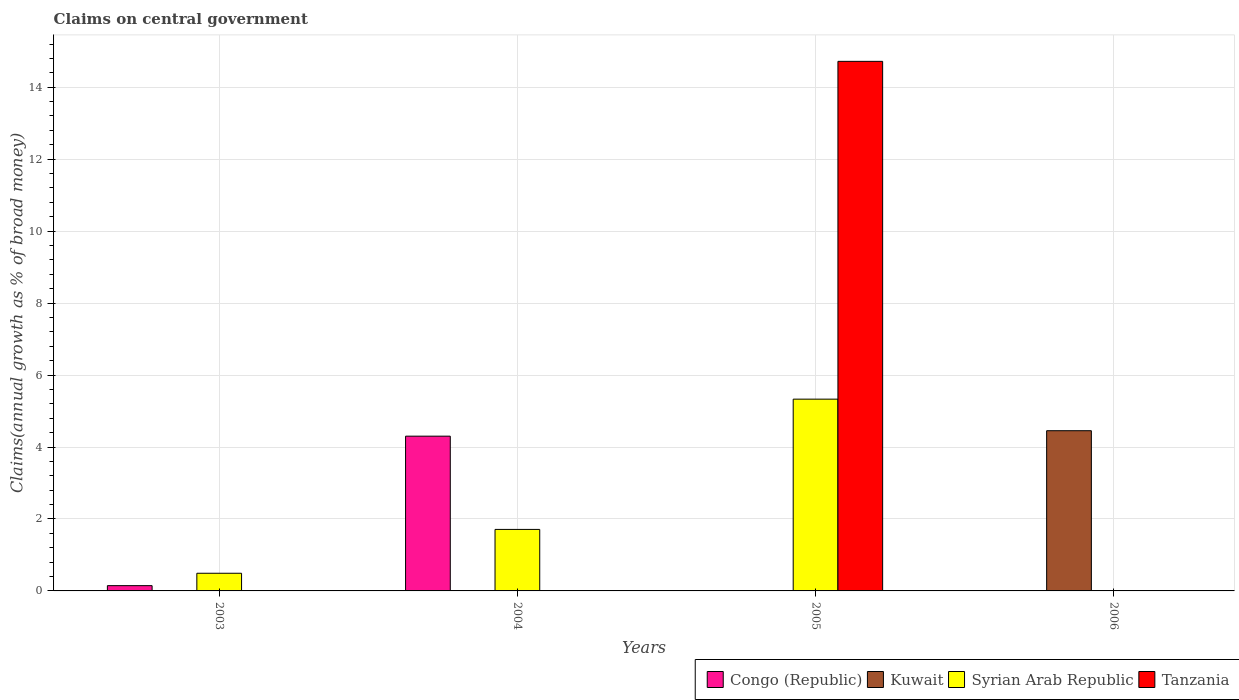How many different coloured bars are there?
Your answer should be compact. 4. How many bars are there on the 3rd tick from the left?
Provide a short and direct response. 2. In how many cases, is the number of bars for a given year not equal to the number of legend labels?
Provide a succinct answer. 4. Across all years, what is the maximum percentage of broad money claimed on centeral government in Syrian Arab Republic?
Offer a very short reply. 5.33. In which year was the percentage of broad money claimed on centeral government in Tanzania maximum?
Ensure brevity in your answer.  2005. What is the total percentage of broad money claimed on centeral government in Kuwait in the graph?
Offer a terse response. 4.45. What is the difference between the percentage of broad money claimed on centeral government in Syrian Arab Republic in 2003 and that in 2004?
Make the answer very short. -1.22. What is the difference between the percentage of broad money claimed on centeral government in Syrian Arab Republic in 2003 and the percentage of broad money claimed on centeral government in Tanzania in 2005?
Offer a very short reply. -14.23. What is the average percentage of broad money claimed on centeral government in Tanzania per year?
Ensure brevity in your answer.  3.68. In the year 2003, what is the difference between the percentage of broad money claimed on centeral government in Syrian Arab Republic and percentage of broad money claimed on centeral government in Congo (Republic)?
Offer a very short reply. 0.34. In how many years, is the percentage of broad money claimed on centeral government in Kuwait greater than 10 %?
Your answer should be very brief. 0. What is the ratio of the percentage of broad money claimed on centeral government in Syrian Arab Republic in 2003 to that in 2004?
Offer a terse response. 0.29. Is the percentage of broad money claimed on centeral government in Syrian Arab Republic in 2003 less than that in 2005?
Provide a succinct answer. Yes. What is the difference between the highest and the second highest percentage of broad money claimed on centeral government in Syrian Arab Republic?
Give a very brief answer. 3.62. What is the difference between the highest and the lowest percentage of broad money claimed on centeral government in Tanzania?
Offer a terse response. 14.72. Is the sum of the percentage of broad money claimed on centeral government in Syrian Arab Republic in 2004 and 2005 greater than the maximum percentage of broad money claimed on centeral government in Congo (Republic) across all years?
Give a very brief answer. Yes. Is it the case that in every year, the sum of the percentage of broad money claimed on centeral government in Tanzania and percentage of broad money claimed on centeral government in Congo (Republic) is greater than the percentage of broad money claimed on centeral government in Kuwait?
Offer a terse response. No. How many bars are there?
Your answer should be very brief. 7. What is the difference between two consecutive major ticks on the Y-axis?
Provide a short and direct response. 2. Does the graph contain any zero values?
Give a very brief answer. Yes. Does the graph contain grids?
Offer a terse response. Yes. Where does the legend appear in the graph?
Your response must be concise. Bottom right. How many legend labels are there?
Provide a short and direct response. 4. What is the title of the graph?
Keep it short and to the point. Claims on central government. What is the label or title of the Y-axis?
Provide a succinct answer. Claims(annual growth as % of broad money). What is the Claims(annual growth as % of broad money) of Congo (Republic) in 2003?
Make the answer very short. 0.15. What is the Claims(annual growth as % of broad money) in Syrian Arab Republic in 2003?
Your answer should be very brief. 0.49. What is the Claims(annual growth as % of broad money) in Congo (Republic) in 2004?
Offer a very short reply. 4.3. What is the Claims(annual growth as % of broad money) of Kuwait in 2004?
Your response must be concise. 0. What is the Claims(annual growth as % of broad money) of Syrian Arab Republic in 2004?
Offer a terse response. 1.71. What is the Claims(annual growth as % of broad money) of Tanzania in 2004?
Make the answer very short. 0. What is the Claims(annual growth as % of broad money) in Congo (Republic) in 2005?
Make the answer very short. 0. What is the Claims(annual growth as % of broad money) in Syrian Arab Republic in 2005?
Make the answer very short. 5.33. What is the Claims(annual growth as % of broad money) of Tanzania in 2005?
Offer a terse response. 14.72. What is the Claims(annual growth as % of broad money) in Congo (Republic) in 2006?
Give a very brief answer. 0. What is the Claims(annual growth as % of broad money) of Kuwait in 2006?
Provide a short and direct response. 4.45. What is the Claims(annual growth as % of broad money) in Tanzania in 2006?
Provide a succinct answer. 0. Across all years, what is the maximum Claims(annual growth as % of broad money) of Congo (Republic)?
Provide a succinct answer. 4.3. Across all years, what is the maximum Claims(annual growth as % of broad money) in Kuwait?
Provide a short and direct response. 4.45. Across all years, what is the maximum Claims(annual growth as % of broad money) of Syrian Arab Republic?
Ensure brevity in your answer.  5.33. Across all years, what is the maximum Claims(annual growth as % of broad money) of Tanzania?
Give a very brief answer. 14.72. Across all years, what is the minimum Claims(annual growth as % of broad money) of Congo (Republic)?
Your response must be concise. 0. Across all years, what is the minimum Claims(annual growth as % of broad money) of Kuwait?
Offer a very short reply. 0. What is the total Claims(annual growth as % of broad money) of Congo (Republic) in the graph?
Provide a succinct answer. 4.45. What is the total Claims(annual growth as % of broad money) in Kuwait in the graph?
Provide a succinct answer. 4.45. What is the total Claims(annual growth as % of broad money) in Syrian Arab Republic in the graph?
Give a very brief answer. 7.53. What is the total Claims(annual growth as % of broad money) in Tanzania in the graph?
Your answer should be compact. 14.72. What is the difference between the Claims(annual growth as % of broad money) in Congo (Republic) in 2003 and that in 2004?
Keep it short and to the point. -4.15. What is the difference between the Claims(annual growth as % of broad money) in Syrian Arab Republic in 2003 and that in 2004?
Give a very brief answer. -1.22. What is the difference between the Claims(annual growth as % of broad money) of Syrian Arab Republic in 2003 and that in 2005?
Your answer should be very brief. -4.84. What is the difference between the Claims(annual growth as % of broad money) in Syrian Arab Republic in 2004 and that in 2005?
Provide a succinct answer. -3.62. What is the difference between the Claims(annual growth as % of broad money) in Congo (Republic) in 2003 and the Claims(annual growth as % of broad money) in Syrian Arab Republic in 2004?
Your answer should be very brief. -1.56. What is the difference between the Claims(annual growth as % of broad money) in Congo (Republic) in 2003 and the Claims(annual growth as % of broad money) in Syrian Arab Republic in 2005?
Your answer should be very brief. -5.18. What is the difference between the Claims(annual growth as % of broad money) of Congo (Republic) in 2003 and the Claims(annual growth as % of broad money) of Tanzania in 2005?
Ensure brevity in your answer.  -14.57. What is the difference between the Claims(annual growth as % of broad money) of Syrian Arab Republic in 2003 and the Claims(annual growth as % of broad money) of Tanzania in 2005?
Give a very brief answer. -14.23. What is the difference between the Claims(annual growth as % of broad money) in Congo (Republic) in 2003 and the Claims(annual growth as % of broad money) in Kuwait in 2006?
Your response must be concise. -4.31. What is the difference between the Claims(annual growth as % of broad money) in Congo (Republic) in 2004 and the Claims(annual growth as % of broad money) in Syrian Arab Republic in 2005?
Your answer should be very brief. -1.03. What is the difference between the Claims(annual growth as % of broad money) of Congo (Republic) in 2004 and the Claims(annual growth as % of broad money) of Tanzania in 2005?
Your answer should be very brief. -10.42. What is the difference between the Claims(annual growth as % of broad money) of Syrian Arab Republic in 2004 and the Claims(annual growth as % of broad money) of Tanzania in 2005?
Offer a very short reply. -13.01. What is the difference between the Claims(annual growth as % of broad money) in Congo (Republic) in 2004 and the Claims(annual growth as % of broad money) in Kuwait in 2006?
Your response must be concise. -0.15. What is the average Claims(annual growth as % of broad money) of Congo (Republic) per year?
Provide a succinct answer. 1.11. What is the average Claims(annual growth as % of broad money) in Kuwait per year?
Your response must be concise. 1.11. What is the average Claims(annual growth as % of broad money) in Syrian Arab Republic per year?
Keep it short and to the point. 1.88. What is the average Claims(annual growth as % of broad money) of Tanzania per year?
Give a very brief answer. 3.68. In the year 2003, what is the difference between the Claims(annual growth as % of broad money) in Congo (Republic) and Claims(annual growth as % of broad money) in Syrian Arab Republic?
Provide a succinct answer. -0.34. In the year 2004, what is the difference between the Claims(annual growth as % of broad money) in Congo (Republic) and Claims(annual growth as % of broad money) in Syrian Arab Republic?
Provide a succinct answer. 2.59. In the year 2005, what is the difference between the Claims(annual growth as % of broad money) of Syrian Arab Republic and Claims(annual growth as % of broad money) of Tanzania?
Your response must be concise. -9.39. What is the ratio of the Claims(annual growth as % of broad money) of Congo (Republic) in 2003 to that in 2004?
Offer a very short reply. 0.03. What is the ratio of the Claims(annual growth as % of broad money) of Syrian Arab Republic in 2003 to that in 2004?
Offer a very short reply. 0.29. What is the ratio of the Claims(annual growth as % of broad money) of Syrian Arab Republic in 2003 to that in 2005?
Give a very brief answer. 0.09. What is the ratio of the Claims(annual growth as % of broad money) in Syrian Arab Republic in 2004 to that in 2005?
Provide a short and direct response. 0.32. What is the difference between the highest and the second highest Claims(annual growth as % of broad money) in Syrian Arab Republic?
Offer a very short reply. 3.62. What is the difference between the highest and the lowest Claims(annual growth as % of broad money) in Congo (Republic)?
Your answer should be very brief. 4.3. What is the difference between the highest and the lowest Claims(annual growth as % of broad money) of Kuwait?
Your answer should be compact. 4.45. What is the difference between the highest and the lowest Claims(annual growth as % of broad money) of Syrian Arab Republic?
Your answer should be very brief. 5.33. What is the difference between the highest and the lowest Claims(annual growth as % of broad money) of Tanzania?
Offer a terse response. 14.72. 